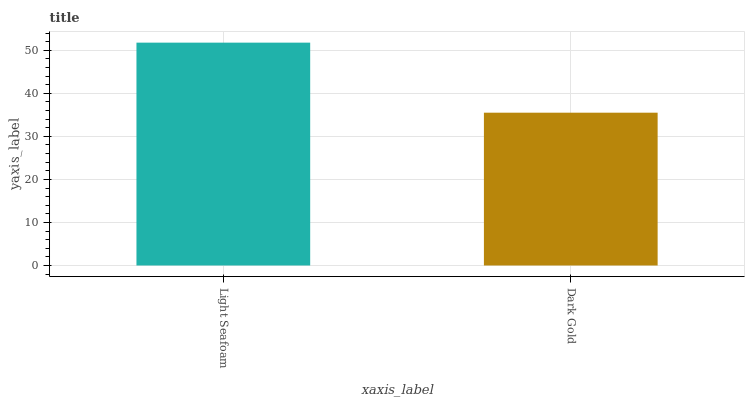Is Dark Gold the minimum?
Answer yes or no. Yes. Is Light Seafoam the maximum?
Answer yes or no. Yes. Is Dark Gold the maximum?
Answer yes or no. No. Is Light Seafoam greater than Dark Gold?
Answer yes or no. Yes. Is Dark Gold less than Light Seafoam?
Answer yes or no. Yes. Is Dark Gold greater than Light Seafoam?
Answer yes or no. No. Is Light Seafoam less than Dark Gold?
Answer yes or no. No. Is Light Seafoam the high median?
Answer yes or no. Yes. Is Dark Gold the low median?
Answer yes or no. Yes. Is Dark Gold the high median?
Answer yes or no. No. Is Light Seafoam the low median?
Answer yes or no. No. 